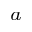Convert formula to latex. <formula><loc_0><loc_0><loc_500><loc_500>^ { a }</formula> 